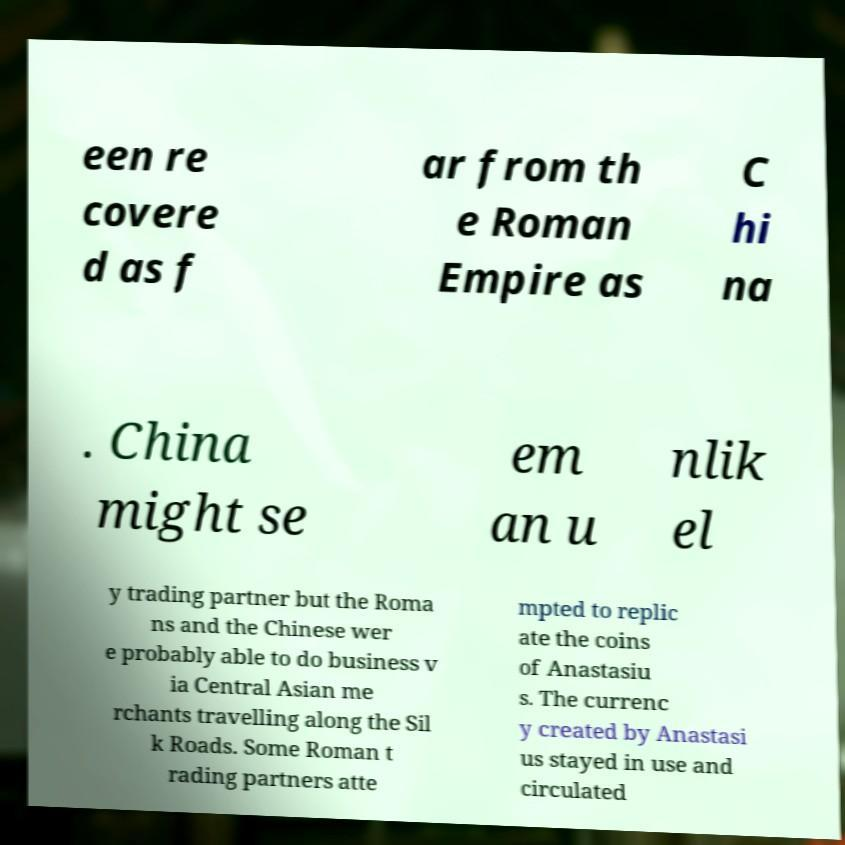There's text embedded in this image that I need extracted. Can you transcribe it verbatim? een re covere d as f ar from th e Roman Empire as C hi na . China might se em an u nlik el y trading partner but the Roma ns and the Chinese wer e probably able to do business v ia Central Asian me rchants travelling along the Sil k Roads. Some Roman t rading partners atte mpted to replic ate the coins of Anastasiu s. The currenc y created by Anastasi us stayed in use and circulated 